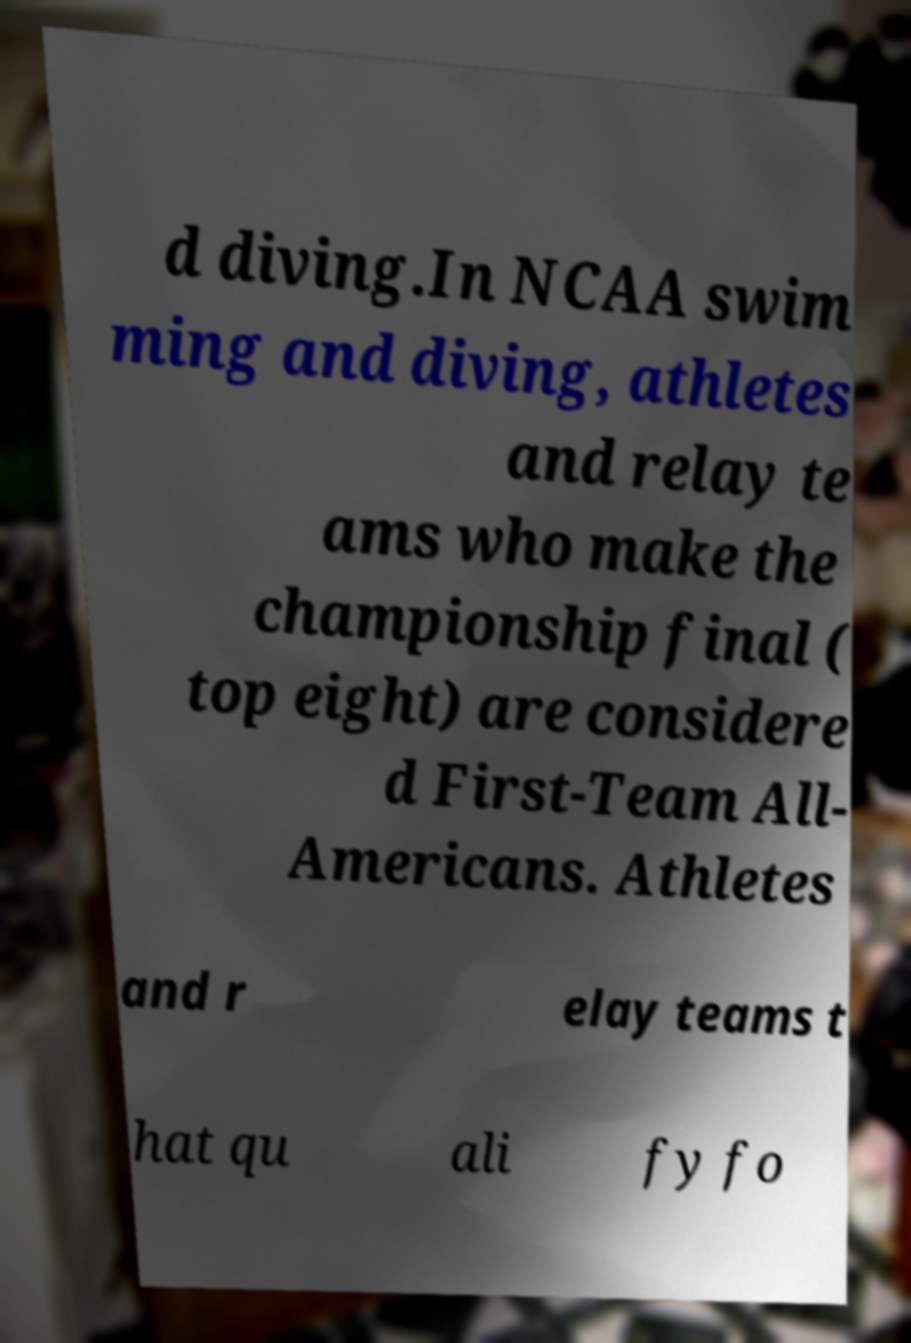Could you extract and type out the text from this image? d diving.In NCAA swim ming and diving, athletes and relay te ams who make the championship final ( top eight) are considere d First-Team All- Americans. Athletes and r elay teams t hat qu ali fy fo 